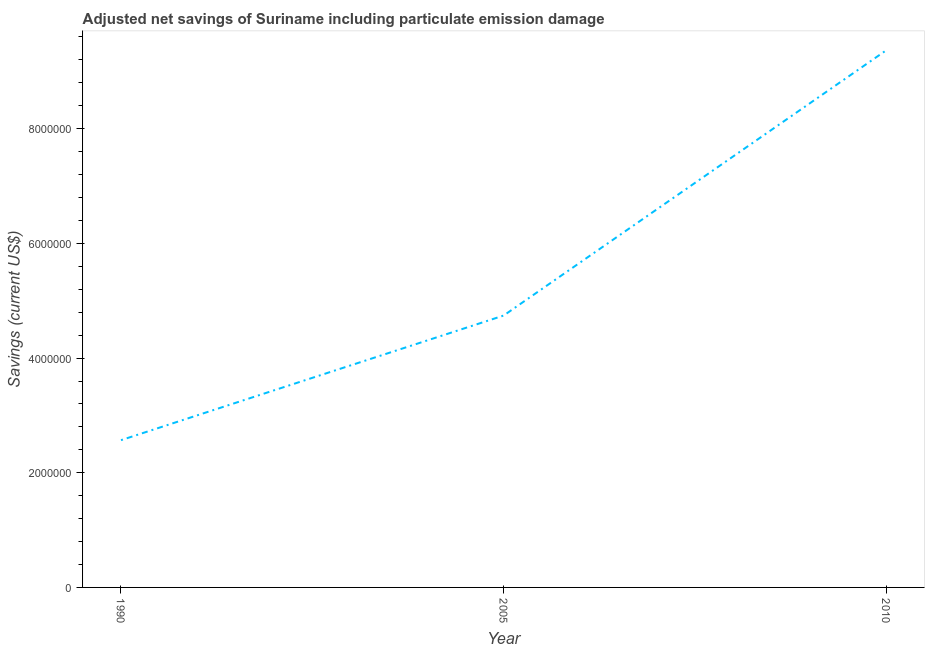What is the adjusted net savings in 2005?
Give a very brief answer. 4.74e+06. Across all years, what is the maximum adjusted net savings?
Your response must be concise. 9.37e+06. Across all years, what is the minimum adjusted net savings?
Provide a succinct answer. 2.57e+06. What is the sum of the adjusted net savings?
Provide a short and direct response. 1.67e+07. What is the difference between the adjusted net savings in 1990 and 2010?
Your response must be concise. -6.80e+06. What is the average adjusted net savings per year?
Offer a very short reply. 5.56e+06. What is the median adjusted net savings?
Offer a very short reply. 4.74e+06. In how many years, is the adjusted net savings greater than 7600000 US$?
Keep it short and to the point. 1. What is the ratio of the adjusted net savings in 1990 to that in 2010?
Provide a succinct answer. 0.27. Is the difference between the adjusted net savings in 1990 and 2010 greater than the difference between any two years?
Provide a succinct answer. Yes. What is the difference between the highest and the second highest adjusted net savings?
Your answer should be compact. 4.63e+06. What is the difference between the highest and the lowest adjusted net savings?
Your response must be concise. 6.80e+06. In how many years, is the adjusted net savings greater than the average adjusted net savings taken over all years?
Your response must be concise. 1. How many years are there in the graph?
Your response must be concise. 3. What is the difference between two consecutive major ticks on the Y-axis?
Make the answer very short. 2.00e+06. What is the title of the graph?
Your answer should be very brief. Adjusted net savings of Suriname including particulate emission damage. What is the label or title of the Y-axis?
Keep it short and to the point. Savings (current US$). What is the Savings (current US$) of 1990?
Your response must be concise. 2.57e+06. What is the Savings (current US$) in 2005?
Offer a terse response. 4.74e+06. What is the Savings (current US$) in 2010?
Ensure brevity in your answer.  9.37e+06. What is the difference between the Savings (current US$) in 1990 and 2005?
Your answer should be very brief. -2.17e+06. What is the difference between the Savings (current US$) in 1990 and 2010?
Provide a short and direct response. -6.80e+06. What is the difference between the Savings (current US$) in 2005 and 2010?
Make the answer very short. -4.63e+06. What is the ratio of the Savings (current US$) in 1990 to that in 2005?
Your response must be concise. 0.54. What is the ratio of the Savings (current US$) in 1990 to that in 2010?
Provide a short and direct response. 0.27. What is the ratio of the Savings (current US$) in 2005 to that in 2010?
Offer a very short reply. 0.51. 